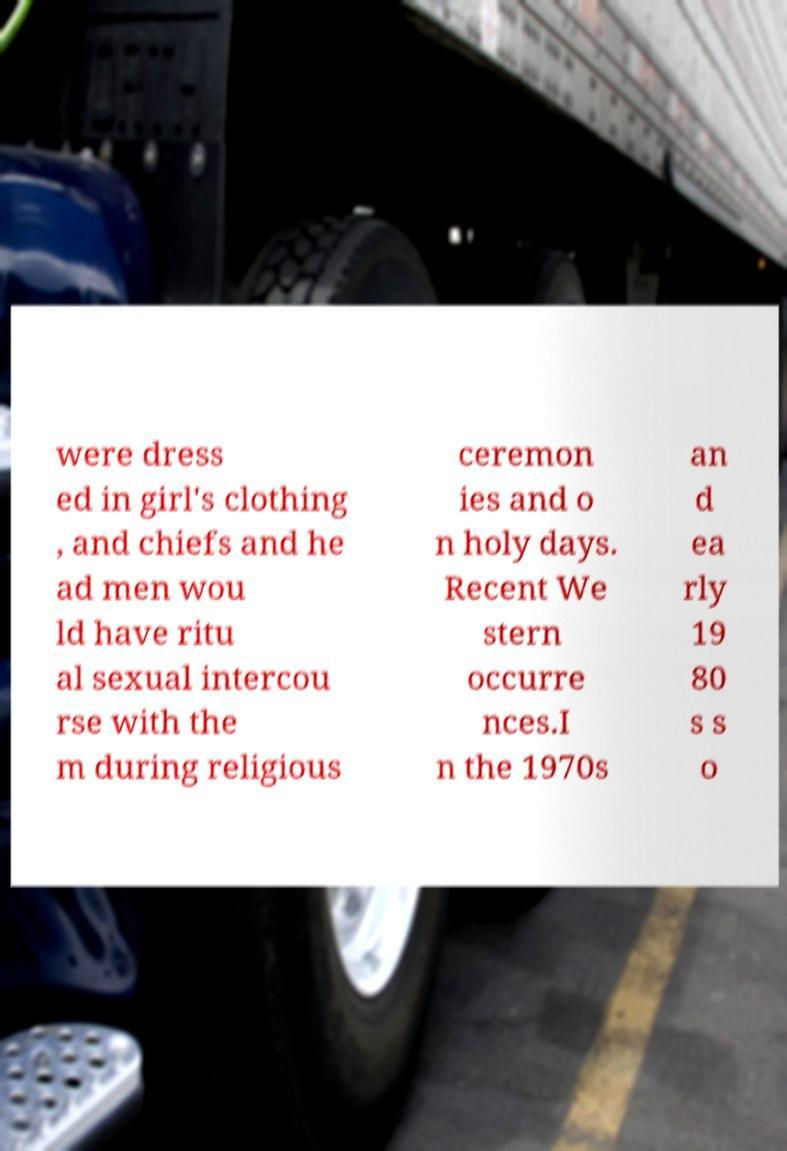There's text embedded in this image that I need extracted. Can you transcribe it verbatim? were dress ed in girl's clothing , and chiefs and he ad men wou ld have ritu al sexual intercou rse with the m during religious ceremon ies and o n holy days. Recent We stern occurre nces.I n the 1970s an d ea rly 19 80 s s o 